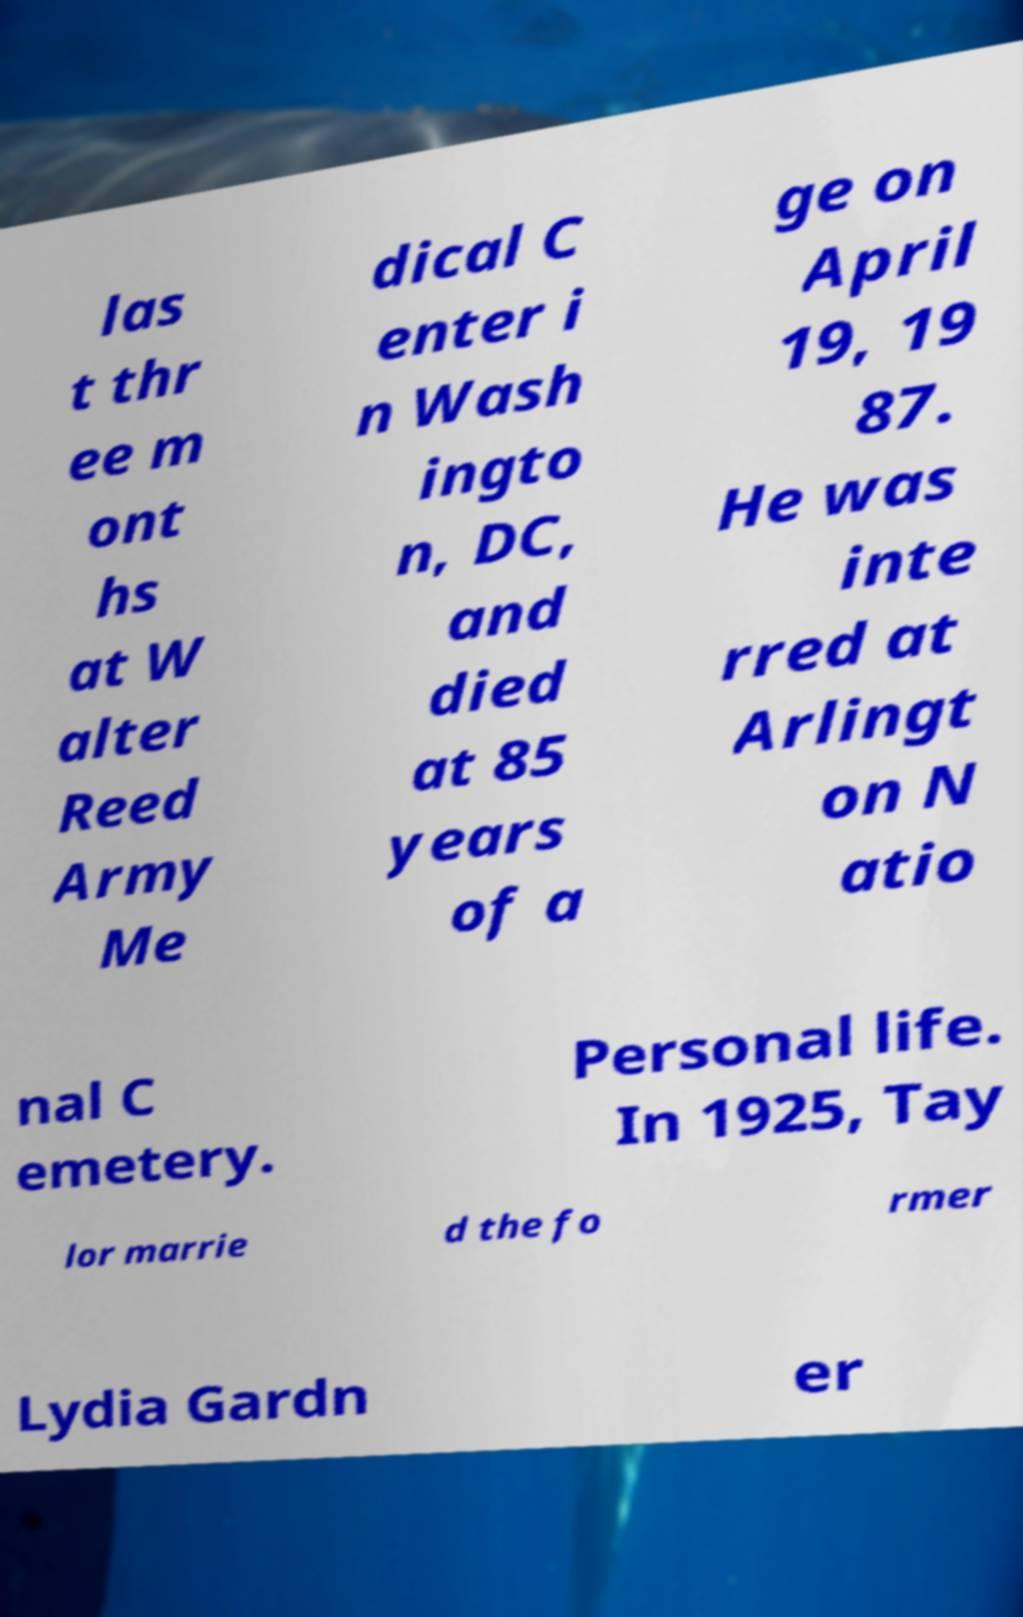What messages or text are displayed in this image? I need them in a readable, typed format. las t thr ee m ont hs at W alter Reed Army Me dical C enter i n Wash ingto n, DC, and died at 85 years of a ge on April 19, 19 87. He was inte rred at Arlingt on N atio nal C emetery. Personal life. In 1925, Tay lor marrie d the fo rmer Lydia Gardn er 